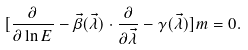Convert formula to latex. <formula><loc_0><loc_0><loc_500><loc_500>[ \frac { \partial } { \partial \ln E } - \vec { \beta } ( \vec { \lambda } ) \cdot \frac { \partial } { \partial \vec { \lambda } } - \gamma ( \vec { \lambda } ) ] m = 0 .</formula> 